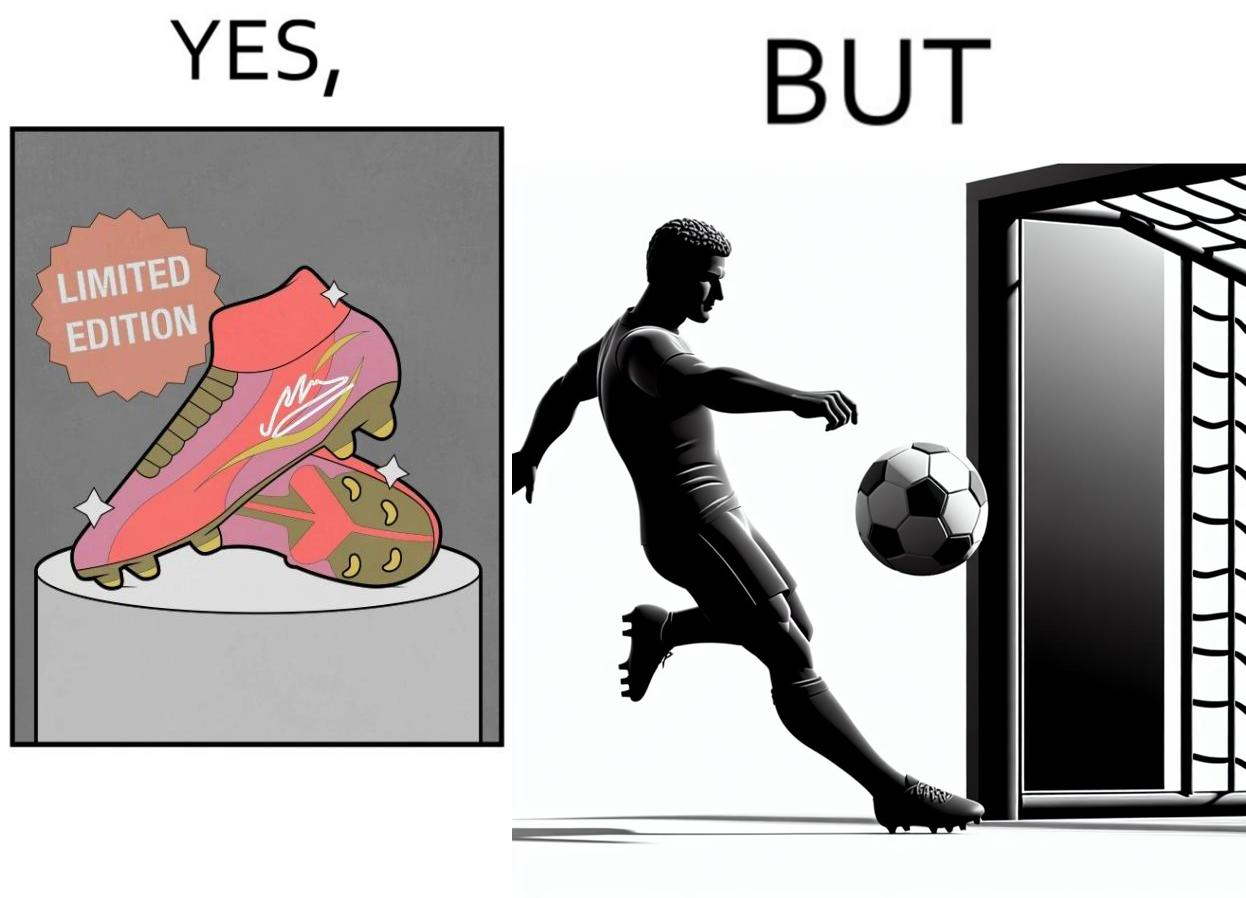Describe the contrast between the left and right parts of this image. In the left part of the image: It is a pair of expensive looking limited edition football boots In the right part of the image: It is a man shooting a football wide outside a goalpost 